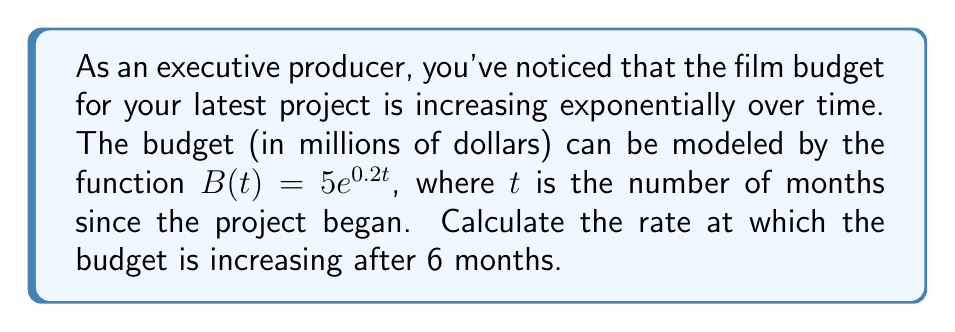Could you help me with this problem? To find the rate at which the budget is increasing after 6 months, we need to calculate the derivative of the budget function $B(t)$ and evaluate it at $t = 6$.

Step 1: Find the derivative of $B(t)$
The derivative of $B(t) = 5e^{0.2t}$ is:
$$\frac{d}{dt}B(t) = 5 \cdot 0.2e^{0.2t} = e^{0.2t}$$

Step 2: Evaluate the derivative at $t = 6$
$$\frac{d}{dt}B(6) = e^{0.2 \cdot 6} = e^{1.2} \approx 3.32$$

Step 3: Interpret the result
The rate of change at $t = 6$ is approximately 3.32 million dollars per month.

This means that after 6 months, the film budget is increasing at a rate of about $3.32 million per month.
Answer: $3.32$ million dollars per month 